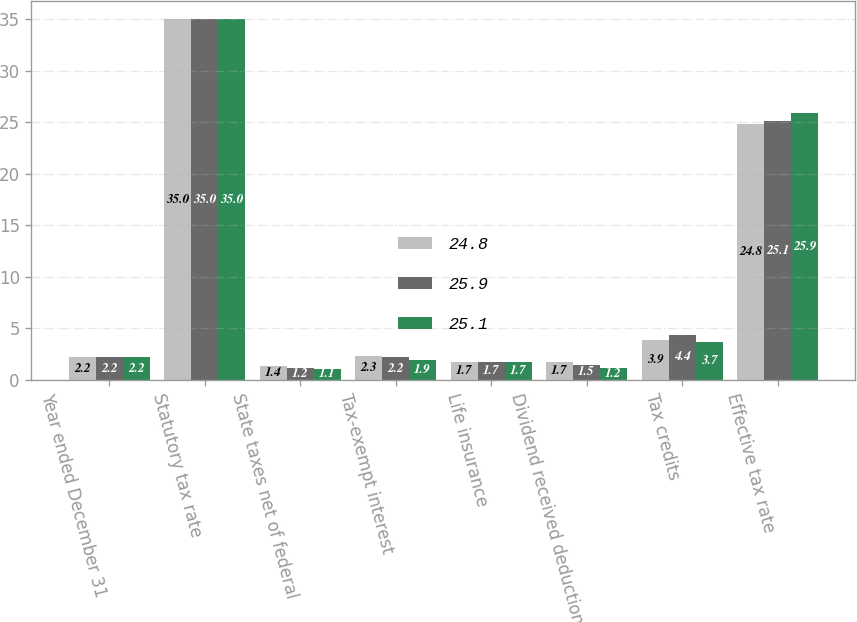<chart> <loc_0><loc_0><loc_500><loc_500><stacked_bar_chart><ecel><fcel>Year ended December 31<fcel>Statutory tax rate<fcel>State taxes net of federal<fcel>Tax-exempt interest<fcel>Life insurance<fcel>Dividend received deduction<fcel>Tax credits<fcel>Effective tax rate<nl><fcel>24.8<fcel>2.2<fcel>35<fcel>1.4<fcel>2.3<fcel>1.7<fcel>1.7<fcel>3.9<fcel>24.8<nl><fcel>25.9<fcel>2.2<fcel>35<fcel>1.2<fcel>2.2<fcel>1.7<fcel>1.5<fcel>4.4<fcel>25.1<nl><fcel>25.1<fcel>2.2<fcel>35<fcel>1.1<fcel>1.9<fcel>1.7<fcel>1.2<fcel>3.7<fcel>25.9<nl></chart> 